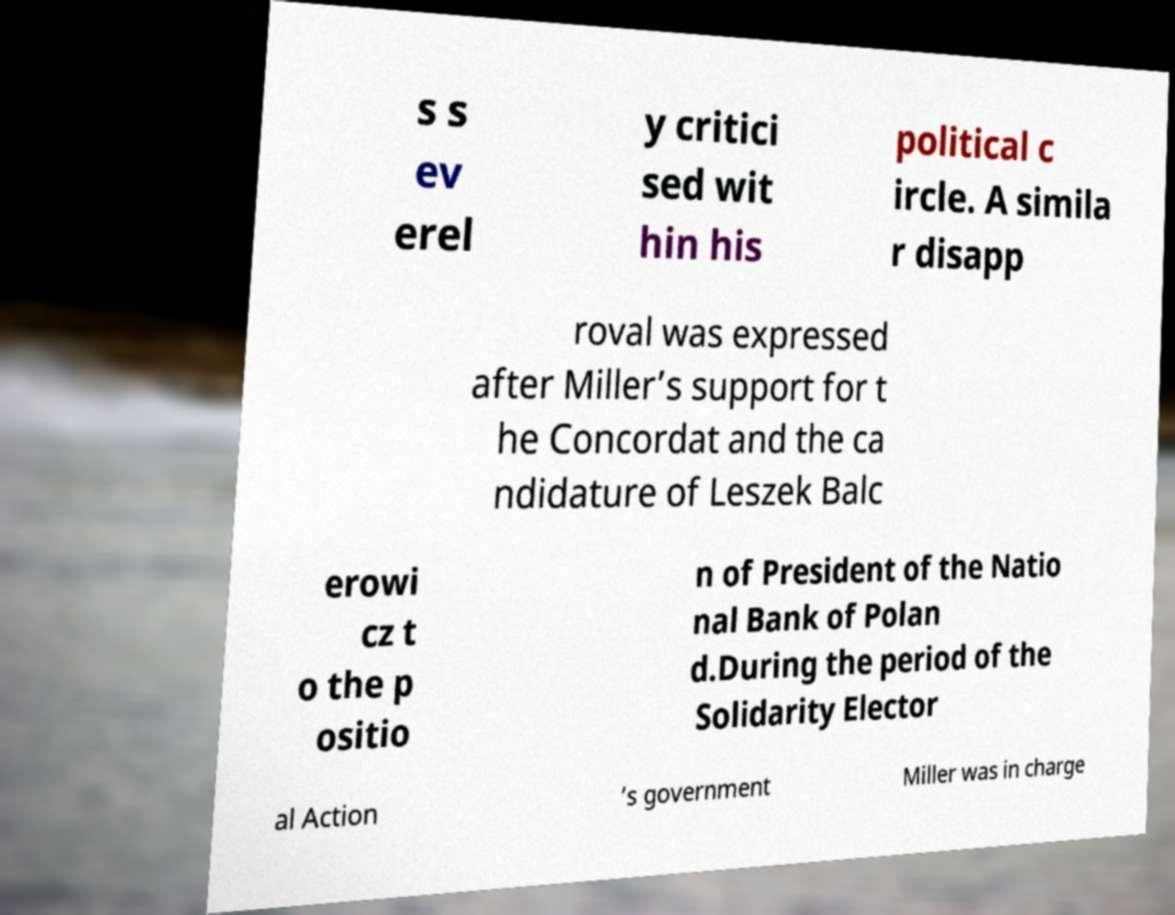For documentation purposes, I need the text within this image transcribed. Could you provide that? s s ev erel y critici sed wit hin his political c ircle. A simila r disapp roval was expressed after Miller’s support for t he Concordat and the ca ndidature of Leszek Balc erowi cz t o the p ositio n of President of the Natio nal Bank of Polan d.During the period of the Solidarity Elector al Action ’s government Miller was in charge 